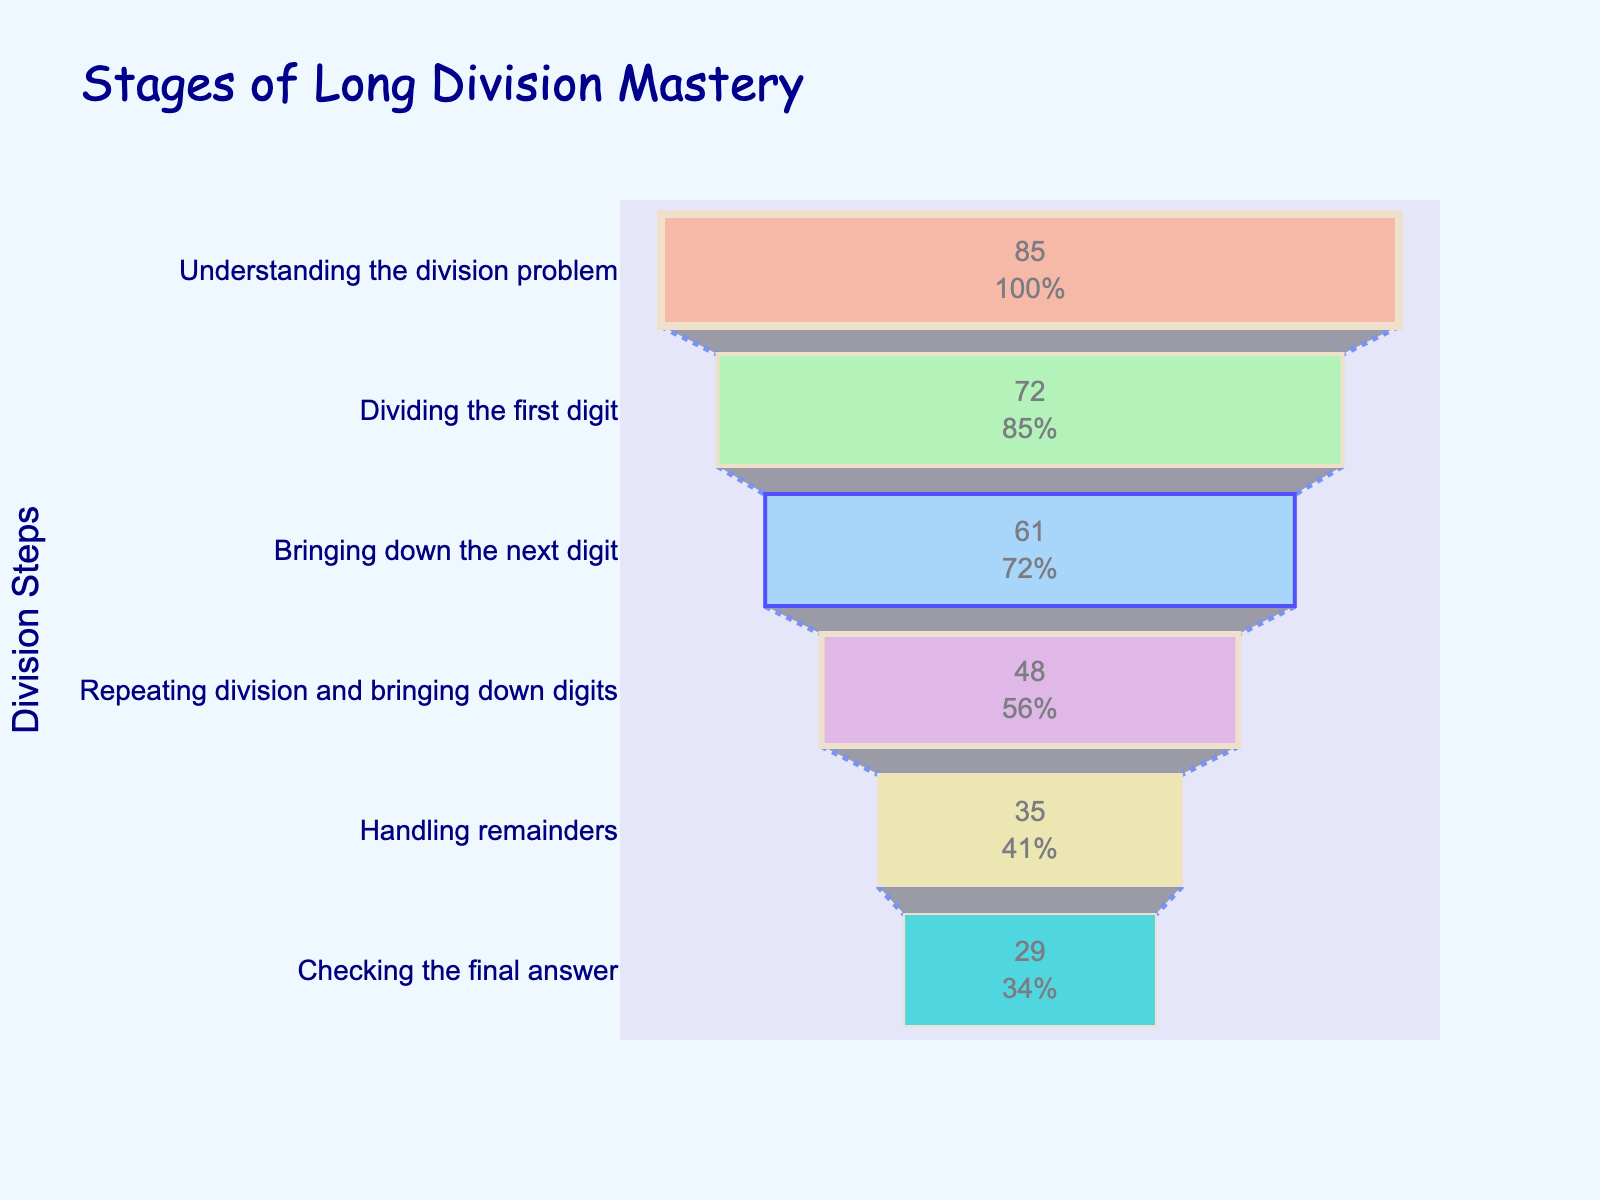What's the title of the figure? The title of the figure is displayed at the top of the chart. It reads "Stages of Long Division Mastery".
Answer: Stages of Long Division Mastery How many steps are displayed in the chart? The funnel chart displays bars representing each step. Counting these bars gives the total number of steps.
Answer: 6 What is the percentage of students who have mastered "Bringing down the next digit"? The percentage associated with the step "Bringing down the next digit" is shown inside the corresponding bar.
Answer: 61% Which step has the highest percentage of students mastering it? By comparing the percentages shown inside each bar, the step with the highest percentage is "Understanding the division problem".
Answer: Understanding the division problem What's the difference in percentage between students mastering "Dividing the first digit" and "Handling remainders"? Subtract the percentage of students mastering "Handling remainders" from the percentage of students mastering "Dividing the first digit". 72% - 35% = 37%
Answer: 37% Which step has the least number of students mastering it? The step with the lowest percentage of students mastering it is "Checking the final answer". This can be concluded by comparing all the percentages.
Answer: Checking the final answer What is the combined percentage of students mastering "Handling remainders" and "Checking the final answer"? Add the percentages of students mastering "Handling remainders" and "Checking the final answer". 35% + 29% = 64%
Answer: 64% How many more students mastered "Understanding the division problem" than "Repeating division and bringing down digits"? Subtract the percentage of students mastering "Repeating division and bringing down digits" from the percentage of students mastering "Understanding the division problem". 85% - 48% = 37%
Answer: 37% What step involves "Bringing down the next digit"? The step directly mentions "Bringing down the next digit".
Answer: Bringing down the next digit Compare "Handling remainders" and "Checking the final answer". Which one has more students mastering it? By comparing their percentages, "Handling remainders" has 35% while "Checking the final answer" has 29%, so "Handling remainders" has more students mastering it.
Answer: Handling remainders 